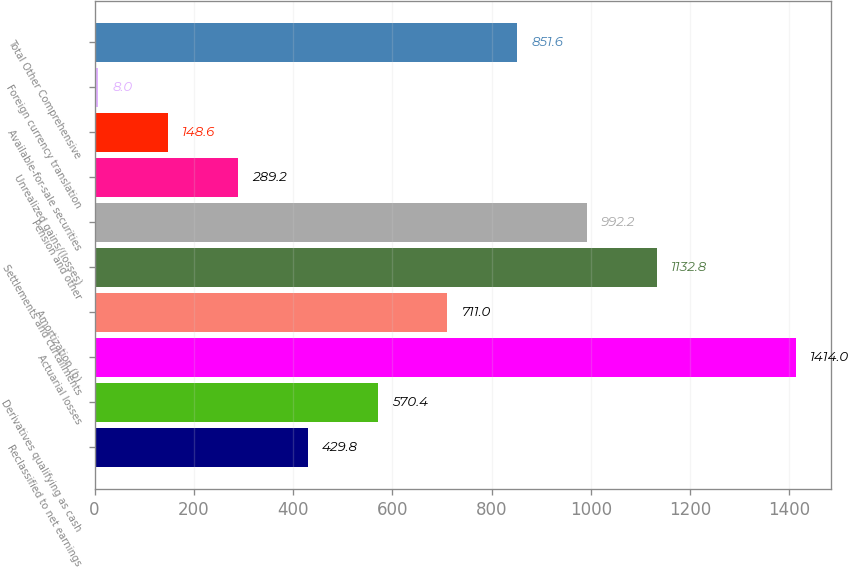Convert chart. <chart><loc_0><loc_0><loc_500><loc_500><bar_chart><fcel>Reclassified to net earnings<fcel>Derivatives qualifying as cash<fcel>Actuarial losses<fcel>Amortization (b)<fcel>Settlements and curtailments<fcel>Pension and other<fcel>Unrealized gains/(losses)<fcel>Available-for-sale securities<fcel>Foreign currency translation<fcel>Total Other Comprehensive<nl><fcel>429.8<fcel>570.4<fcel>1414<fcel>711<fcel>1132.8<fcel>992.2<fcel>289.2<fcel>148.6<fcel>8<fcel>851.6<nl></chart> 